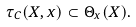<formula> <loc_0><loc_0><loc_500><loc_500>\tau _ { C } ( X , x ) \subset \Theta _ { x } ( X ) .</formula> 